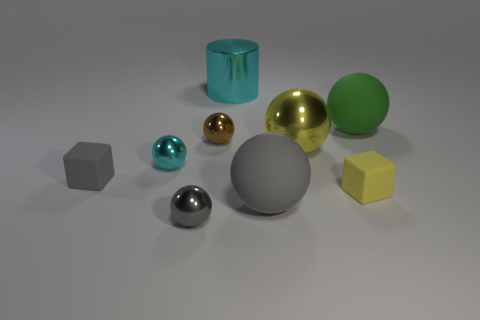Can you describe the lighting and shadows in the scene? The lighting in the scene appears to be soft and diffused, with shadows cast to the foreground, suggesting the light source is above and slightly in front of the objects. There are subtle highlights on the metallic objects, indicating a well-lit environment. 